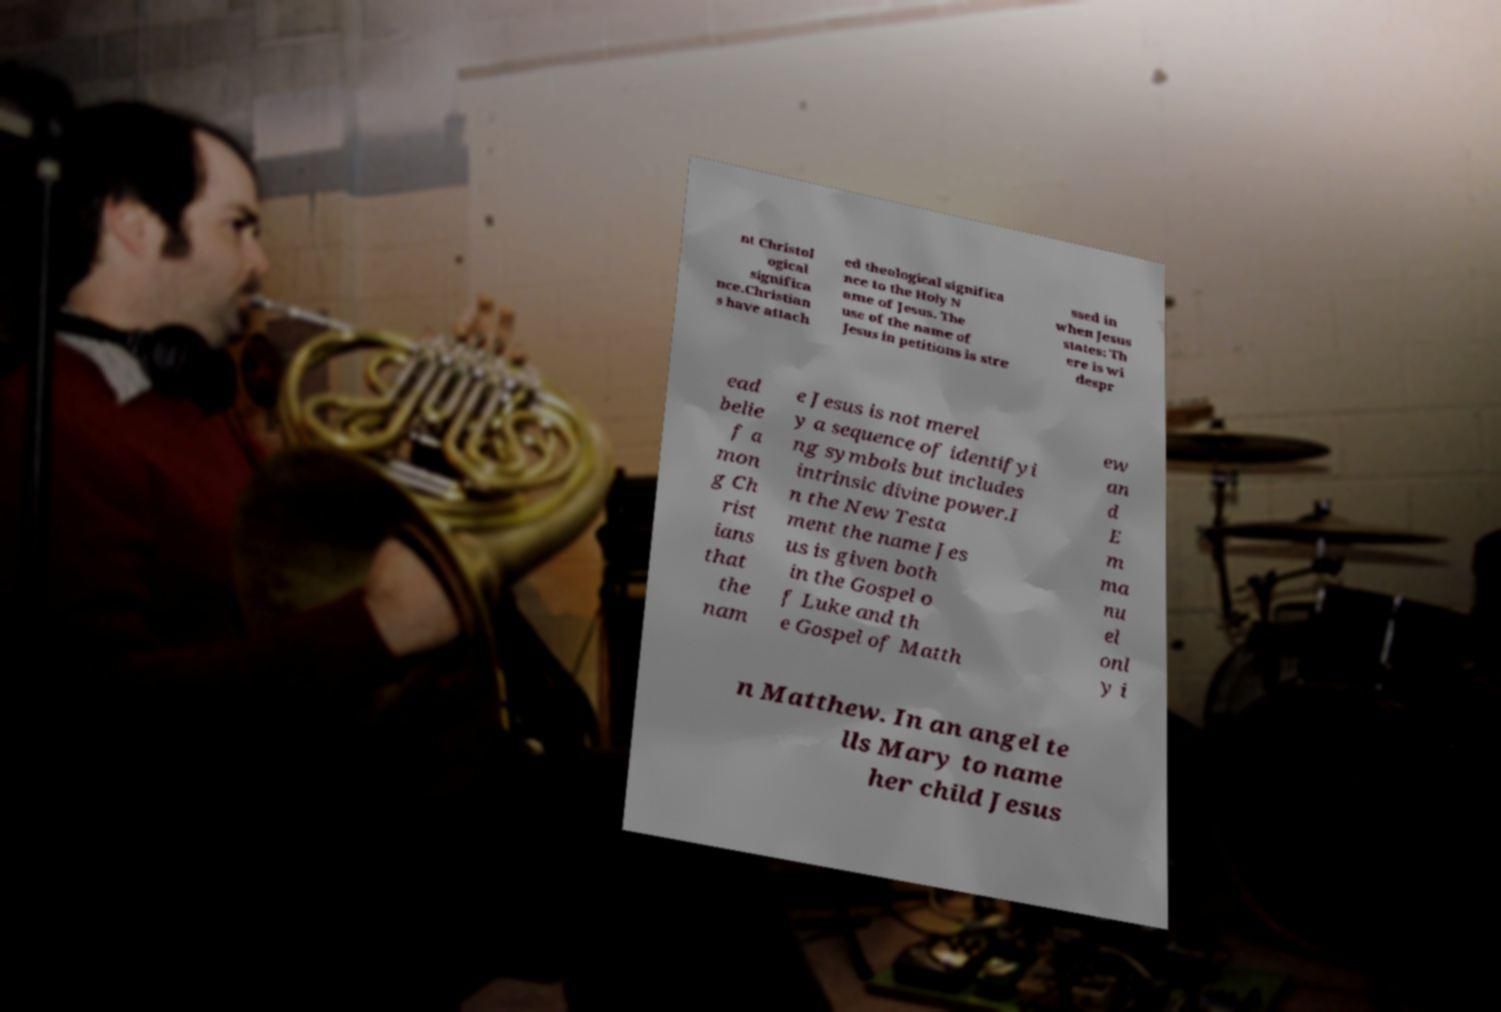Can you read and provide the text displayed in the image?This photo seems to have some interesting text. Can you extract and type it out for me? nt Christol ogical significa nce.Christian s have attach ed theological significa nce to the Holy N ame of Jesus. The use of the name of Jesus in petitions is stre ssed in when Jesus states: Th ere is wi despr ead belie f a mon g Ch rist ians that the nam e Jesus is not merel y a sequence of identifyi ng symbols but includes intrinsic divine power.I n the New Testa ment the name Jes us is given both in the Gospel o f Luke and th e Gospel of Matth ew an d E m ma nu el onl y i n Matthew. In an angel te lls Mary to name her child Jesus 